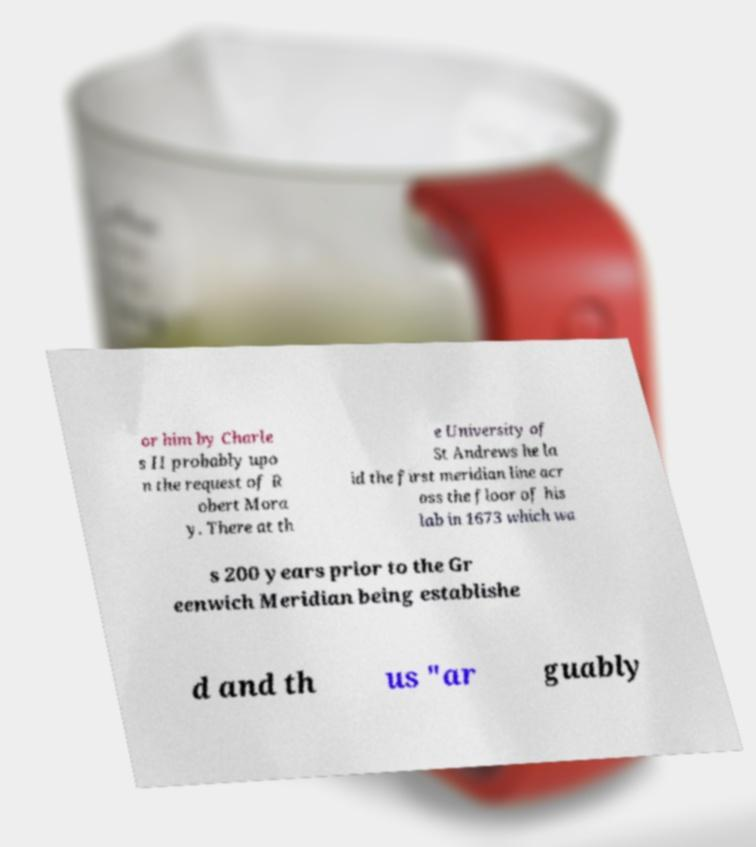Can you accurately transcribe the text from the provided image for me? or him by Charle s II probably upo n the request of R obert Mora y. There at th e University of St Andrews he la id the first meridian line acr oss the floor of his lab in 1673 which wa s 200 years prior to the Gr eenwich Meridian being establishe d and th us "ar guably 